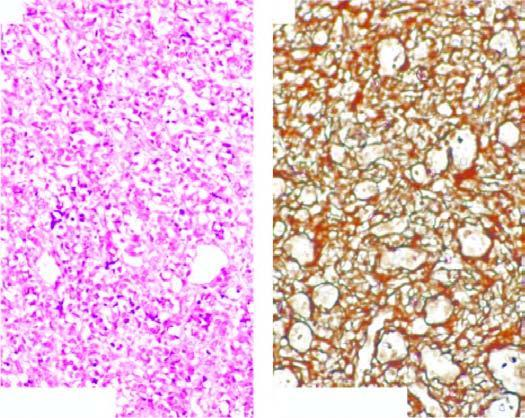does reticulin stain show condensation of reticulin around the vessel wall but not between the proliferating cells?
Answer the question using a single word or phrase. Yes 